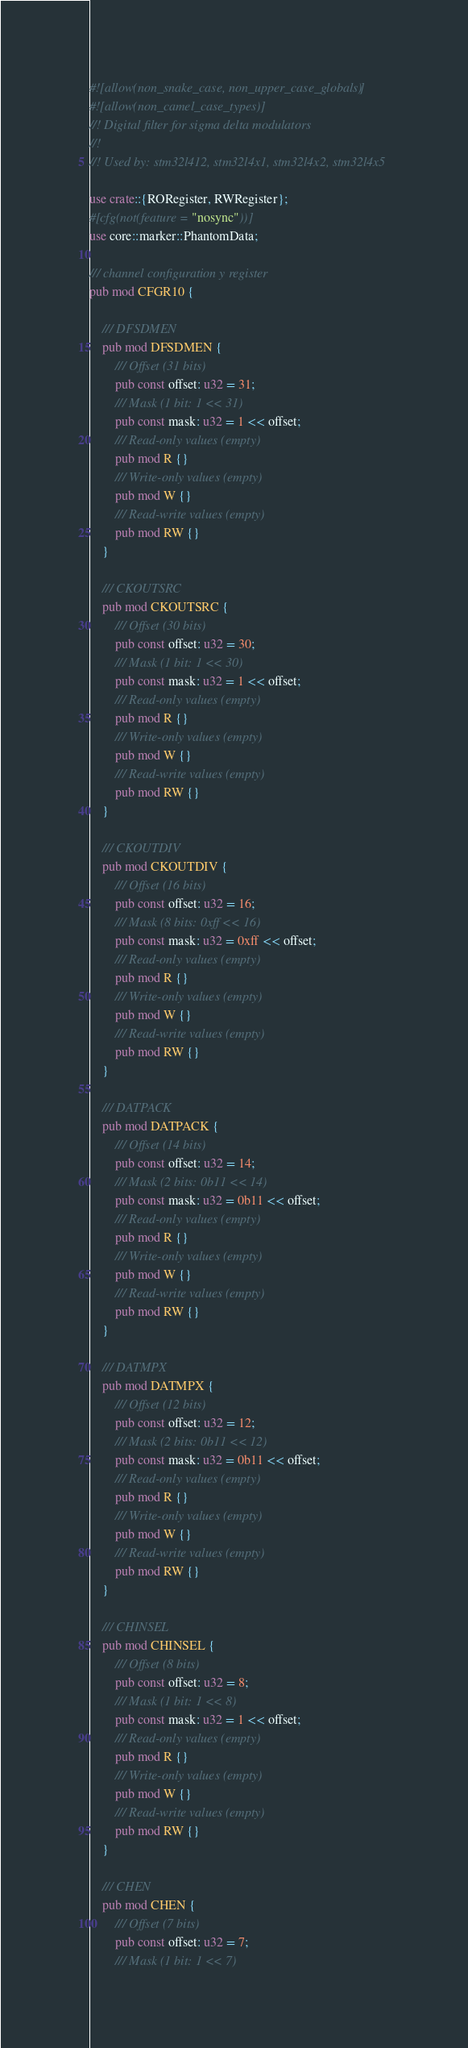Convert code to text. <code><loc_0><loc_0><loc_500><loc_500><_Rust_>#![allow(non_snake_case, non_upper_case_globals)]
#![allow(non_camel_case_types)]
//! Digital filter for sigma delta modulators
//!
//! Used by: stm32l412, stm32l4x1, stm32l4x2, stm32l4x5

use crate::{RORegister, RWRegister};
#[cfg(not(feature = "nosync"))]
use core::marker::PhantomData;

/// channel configuration y register
pub mod CFGR10 {

    /// DFSDMEN
    pub mod DFSDMEN {
        /// Offset (31 bits)
        pub const offset: u32 = 31;
        /// Mask (1 bit: 1 << 31)
        pub const mask: u32 = 1 << offset;
        /// Read-only values (empty)
        pub mod R {}
        /// Write-only values (empty)
        pub mod W {}
        /// Read-write values (empty)
        pub mod RW {}
    }

    /// CKOUTSRC
    pub mod CKOUTSRC {
        /// Offset (30 bits)
        pub const offset: u32 = 30;
        /// Mask (1 bit: 1 << 30)
        pub const mask: u32 = 1 << offset;
        /// Read-only values (empty)
        pub mod R {}
        /// Write-only values (empty)
        pub mod W {}
        /// Read-write values (empty)
        pub mod RW {}
    }

    /// CKOUTDIV
    pub mod CKOUTDIV {
        /// Offset (16 bits)
        pub const offset: u32 = 16;
        /// Mask (8 bits: 0xff << 16)
        pub const mask: u32 = 0xff << offset;
        /// Read-only values (empty)
        pub mod R {}
        /// Write-only values (empty)
        pub mod W {}
        /// Read-write values (empty)
        pub mod RW {}
    }

    /// DATPACK
    pub mod DATPACK {
        /// Offset (14 bits)
        pub const offset: u32 = 14;
        /// Mask (2 bits: 0b11 << 14)
        pub const mask: u32 = 0b11 << offset;
        /// Read-only values (empty)
        pub mod R {}
        /// Write-only values (empty)
        pub mod W {}
        /// Read-write values (empty)
        pub mod RW {}
    }

    /// DATMPX
    pub mod DATMPX {
        /// Offset (12 bits)
        pub const offset: u32 = 12;
        /// Mask (2 bits: 0b11 << 12)
        pub const mask: u32 = 0b11 << offset;
        /// Read-only values (empty)
        pub mod R {}
        /// Write-only values (empty)
        pub mod W {}
        /// Read-write values (empty)
        pub mod RW {}
    }

    /// CHINSEL
    pub mod CHINSEL {
        /// Offset (8 bits)
        pub const offset: u32 = 8;
        /// Mask (1 bit: 1 << 8)
        pub const mask: u32 = 1 << offset;
        /// Read-only values (empty)
        pub mod R {}
        /// Write-only values (empty)
        pub mod W {}
        /// Read-write values (empty)
        pub mod RW {}
    }

    /// CHEN
    pub mod CHEN {
        /// Offset (7 bits)
        pub const offset: u32 = 7;
        /// Mask (1 bit: 1 << 7)</code> 